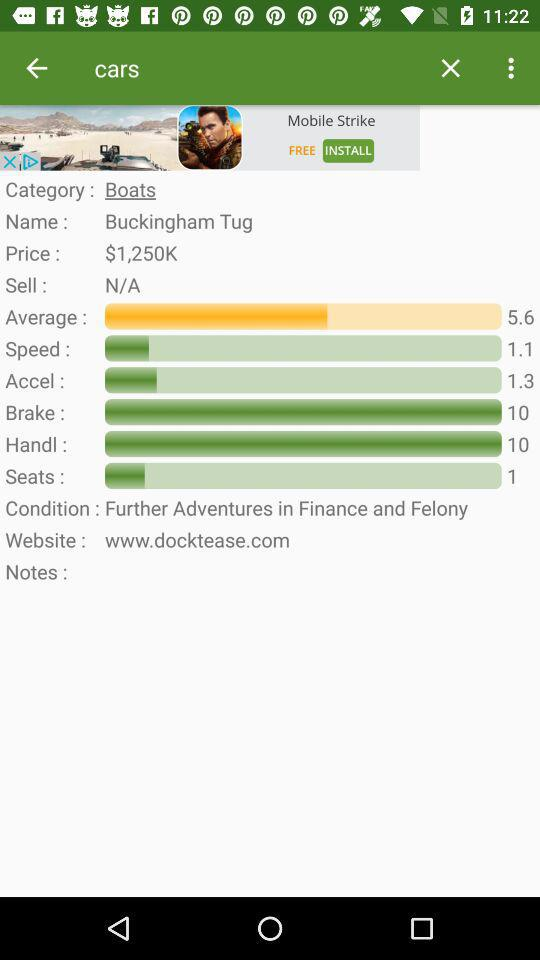What is the user name? The user name is Buckingham Tug. 